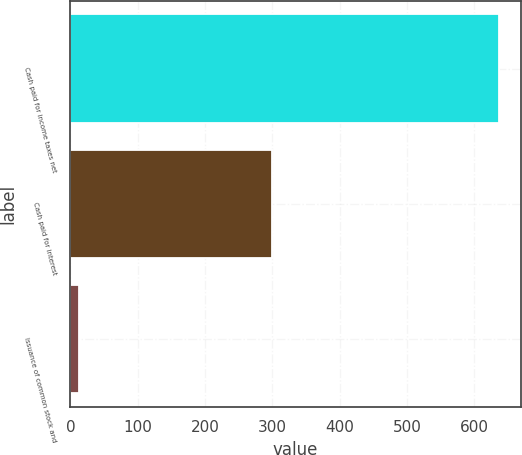<chart> <loc_0><loc_0><loc_500><loc_500><bar_chart><fcel>Cash paid for income taxes net<fcel>Cash paid for interest<fcel>Issuance of common stock and<nl><fcel>637<fcel>299<fcel>13<nl></chart> 